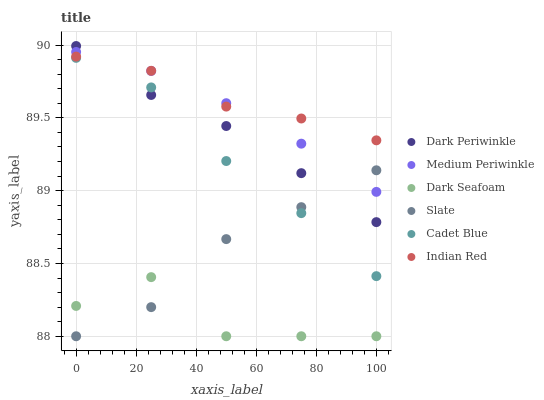Does Dark Seafoam have the minimum area under the curve?
Answer yes or no. Yes. Does Indian Red have the maximum area under the curve?
Answer yes or no. Yes. Does Slate have the minimum area under the curve?
Answer yes or no. No. Does Slate have the maximum area under the curve?
Answer yes or no. No. Is Medium Periwinkle the smoothest?
Answer yes or no. Yes. Is Dark Seafoam the roughest?
Answer yes or no. Yes. Is Slate the smoothest?
Answer yes or no. No. Is Slate the roughest?
Answer yes or no. No. Does Slate have the lowest value?
Answer yes or no. Yes. Does Medium Periwinkle have the lowest value?
Answer yes or no. No. Does Dark Periwinkle have the highest value?
Answer yes or no. Yes. Does Slate have the highest value?
Answer yes or no. No. Is Dark Seafoam less than Cadet Blue?
Answer yes or no. Yes. Is Indian Red greater than Cadet Blue?
Answer yes or no. Yes. Does Dark Periwinkle intersect Indian Red?
Answer yes or no. Yes. Is Dark Periwinkle less than Indian Red?
Answer yes or no. No. Is Dark Periwinkle greater than Indian Red?
Answer yes or no. No. Does Dark Seafoam intersect Cadet Blue?
Answer yes or no. No. 